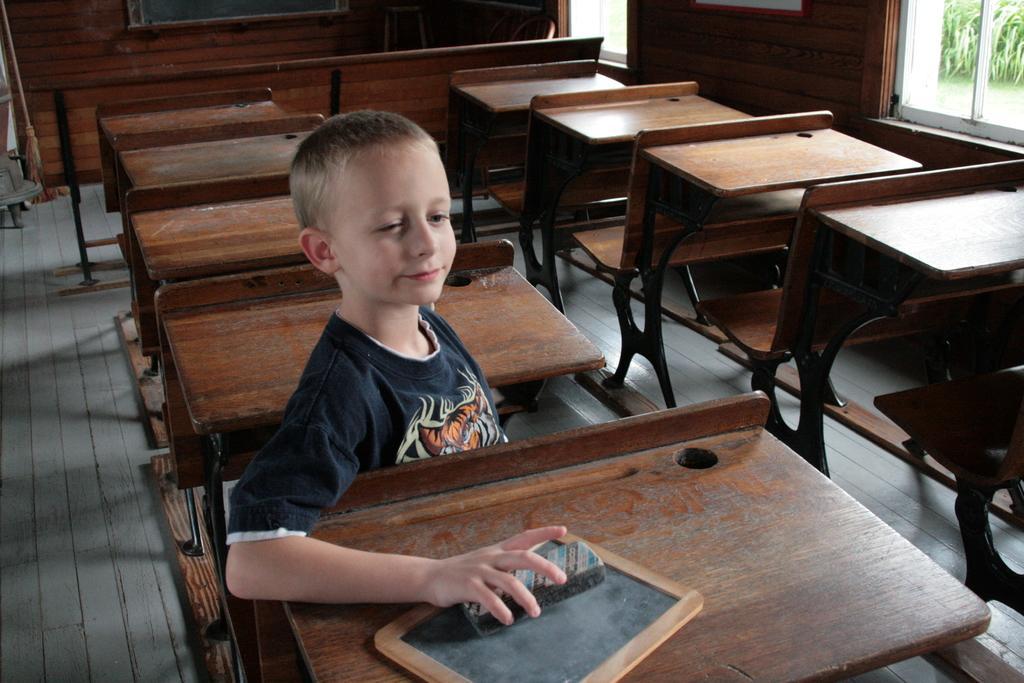Describe this image in one or two sentences. This image is clicked in a classroom. There is a boy sitting in a chair and wearing a black t-shirt. There are many benches in this room. They are made up of wood. To the right, there is a window through which plants are seen. 